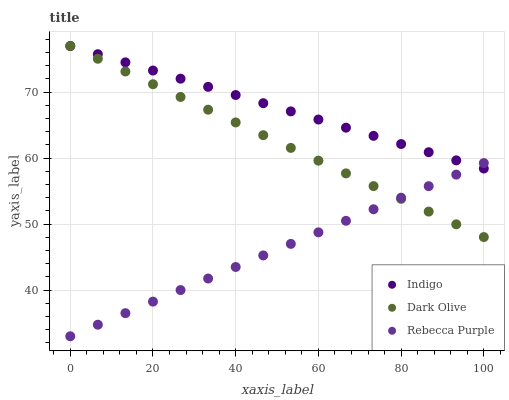Does Rebecca Purple have the minimum area under the curve?
Answer yes or no. Yes. Does Indigo have the maximum area under the curve?
Answer yes or no. Yes. Does Indigo have the minimum area under the curve?
Answer yes or no. No. Does Rebecca Purple have the maximum area under the curve?
Answer yes or no. No. Is Dark Olive the smoothest?
Answer yes or no. Yes. Is Indigo the roughest?
Answer yes or no. Yes. Is Rebecca Purple the smoothest?
Answer yes or no. No. Is Rebecca Purple the roughest?
Answer yes or no. No. Does Rebecca Purple have the lowest value?
Answer yes or no. Yes. Does Indigo have the lowest value?
Answer yes or no. No. Does Indigo have the highest value?
Answer yes or no. Yes. Does Rebecca Purple have the highest value?
Answer yes or no. No. Does Dark Olive intersect Indigo?
Answer yes or no. Yes. Is Dark Olive less than Indigo?
Answer yes or no. No. Is Dark Olive greater than Indigo?
Answer yes or no. No. 